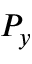Convert formula to latex. <formula><loc_0><loc_0><loc_500><loc_500>P _ { y }</formula> 